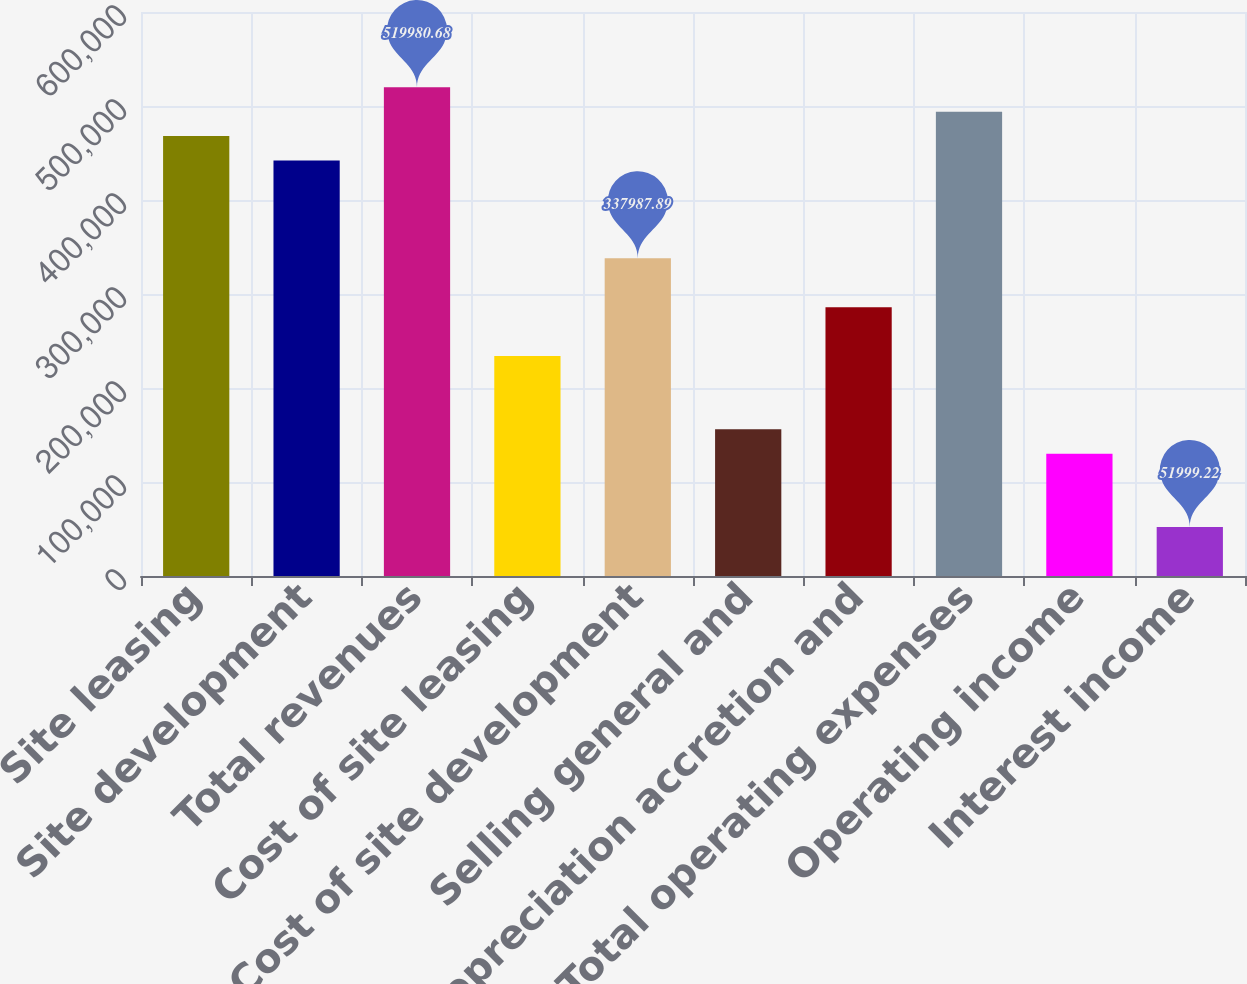Convert chart. <chart><loc_0><loc_0><loc_500><loc_500><bar_chart><fcel>Site leasing<fcel>Site development<fcel>Total revenues<fcel>Cost of site leasing<fcel>Cost of site development<fcel>Selling general and<fcel>Depreciation accretion and<fcel>Total operating expenses<fcel>Operating income<fcel>Interest income<nl><fcel>467983<fcel>441984<fcel>519981<fcel>233992<fcel>337988<fcel>155995<fcel>285990<fcel>493982<fcel>129996<fcel>51999.2<nl></chart> 